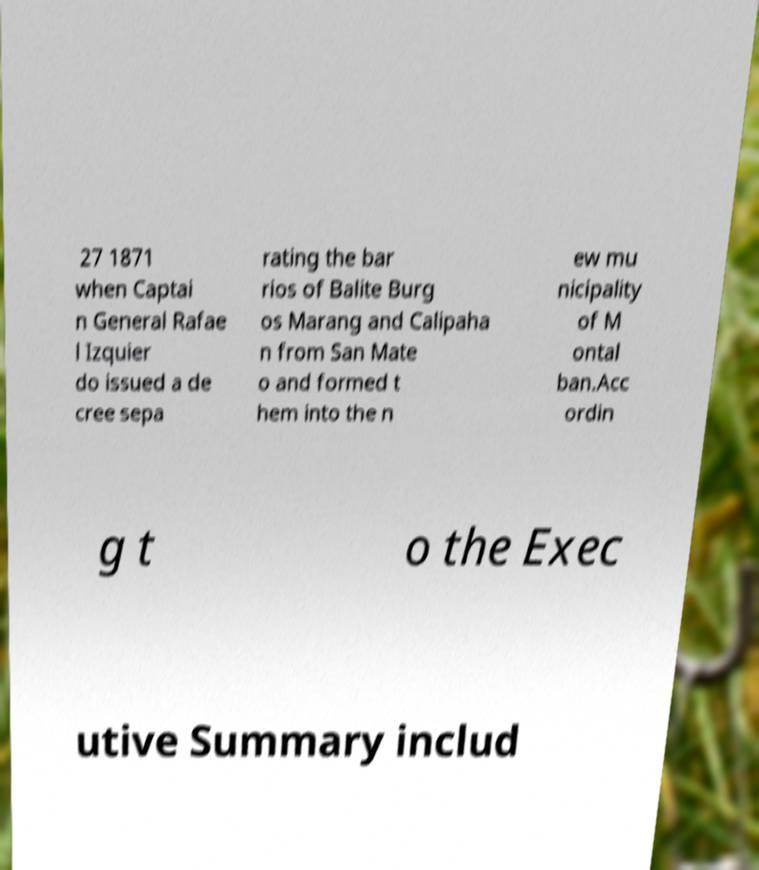Please identify and transcribe the text found in this image. 27 1871 when Captai n General Rafae l Izquier do issued a de cree sepa rating the bar rios of Balite Burg os Marang and Calipaha n from San Mate o and formed t hem into the n ew mu nicipality of M ontal ban.Acc ordin g t o the Exec utive Summary includ 